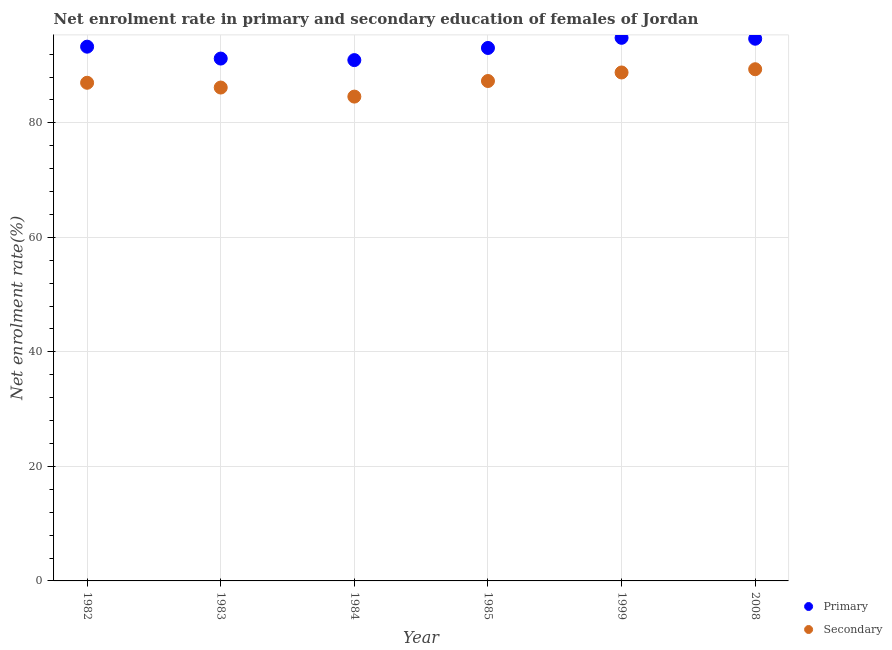How many different coloured dotlines are there?
Offer a very short reply. 2. What is the enrollment rate in primary education in 1985?
Your response must be concise. 93.08. Across all years, what is the maximum enrollment rate in primary education?
Give a very brief answer. 94.85. Across all years, what is the minimum enrollment rate in secondary education?
Offer a terse response. 84.59. In which year was the enrollment rate in primary education minimum?
Give a very brief answer. 1984. What is the total enrollment rate in secondary education in the graph?
Ensure brevity in your answer.  523.24. What is the difference between the enrollment rate in secondary education in 1982 and that in 1985?
Your answer should be compact. -0.31. What is the difference between the enrollment rate in secondary education in 1985 and the enrollment rate in primary education in 1999?
Ensure brevity in your answer.  -7.54. What is the average enrollment rate in secondary education per year?
Your answer should be compact. 87.21. In the year 1983, what is the difference between the enrollment rate in secondary education and enrollment rate in primary education?
Provide a succinct answer. -5.06. What is the ratio of the enrollment rate in primary education in 1982 to that in 1999?
Provide a succinct answer. 0.98. What is the difference between the highest and the second highest enrollment rate in secondary education?
Your answer should be compact. 0.57. What is the difference between the highest and the lowest enrollment rate in primary education?
Keep it short and to the point. 3.89. Is the enrollment rate in primary education strictly greater than the enrollment rate in secondary education over the years?
Your response must be concise. Yes. How many years are there in the graph?
Make the answer very short. 6. How many legend labels are there?
Provide a short and direct response. 2. How are the legend labels stacked?
Keep it short and to the point. Vertical. What is the title of the graph?
Provide a short and direct response. Net enrolment rate in primary and secondary education of females of Jordan. Does "Nitrous oxide" appear as one of the legend labels in the graph?
Your answer should be compact. No. What is the label or title of the Y-axis?
Offer a very short reply. Net enrolment rate(%). What is the Net enrolment rate(%) of Primary in 1982?
Provide a short and direct response. 93.31. What is the Net enrolment rate(%) in Secondary in 1982?
Your answer should be very brief. 87. What is the Net enrolment rate(%) of Primary in 1983?
Offer a terse response. 91.23. What is the Net enrolment rate(%) in Secondary in 1983?
Provide a succinct answer. 86.17. What is the Net enrolment rate(%) of Primary in 1984?
Your answer should be compact. 90.96. What is the Net enrolment rate(%) in Secondary in 1984?
Offer a very short reply. 84.59. What is the Net enrolment rate(%) in Primary in 1985?
Offer a very short reply. 93.08. What is the Net enrolment rate(%) of Secondary in 1985?
Ensure brevity in your answer.  87.31. What is the Net enrolment rate(%) of Primary in 1999?
Your answer should be very brief. 94.85. What is the Net enrolment rate(%) in Secondary in 1999?
Give a very brief answer. 88.8. What is the Net enrolment rate(%) of Primary in 2008?
Offer a terse response. 94.7. What is the Net enrolment rate(%) in Secondary in 2008?
Make the answer very short. 89.37. Across all years, what is the maximum Net enrolment rate(%) of Primary?
Offer a very short reply. 94.85. Across all years, what is the maximum Net enrolment rate(%) of Secondary?
Provide a short and direct response. 89.37. Across all years, what is the minimum Net enrolment rate(%) in Primary?
Your answer should be compact. 90.96. Across all years, what is the minimum Net enrolment rate(%) in Secondary?
Your answer should be compact. 84.59. What is the total Net enrolment rate(%) in Primary in the graph?
Offer a very short reply. 558.13. What is the total Net enrolment rate(%) of Secondary in the graph?
Provide a short and direct response. 523.24. What is the difference between the Net enrolment rate(%) in Primary in 1982 and that in 1983?
Make the answer very short. 2.08. What is the difference between the Net enrolment rate(%) of Secondary in 1982 and that in 1983?
Provide a succinct answer. 0.83. What is the difference between the Net enrolment rate(%) of Primary in 1982 and that in 1984?
Your answer should be compact. 2.35. What is the difference between the Net enrolment rate(%) of Secondary in 1982 and that in 1984?
Offer a terse response. 2.42. What is the difference between the Net enrolment rate(%) of Primary in 1982 and that in 1985?
Keep it short and to the point. 0.23. What is the difference between the Net enrolment rate(%) of Secondary in 1982 and that in 1985?
Ensure brevity in your answer.  -0.31. What is the difference between the Net enrolment rate(%) in Primary in 1982 and that in 1999?
Offer a terse response. -1.55. What is the difference between the Net enrolment rate(%) in Secondary in 1982 and that in 1999?
Keep it short and to the point. -1.8. What is the difference between the Net enrolment rate(%) in Primary in 1982 and that in 2008?
Your answer should be very brief. -1.39. What is the difference between the Net enrolment rate(%) in Secondary in 1982 and that in 2008?
Provide a succinct answer. -2.37. What is the difference between the Net enrolment rate(%) of Primary in 1983 and that in 1984?
Your answer should be very brief. 0.27. What is the difference between the Net enrolment rate(%) in Secondary in 1983 and that in 1984?
Offer a terse response. 1.58. What is the difference between the Net enrolment rate(%) of Primary in 1983 and that in 1985?
Give a very brief answer. -1.85. What is the difference between the Net enrolment rate(%) in Secondary in 1983 and that in 1985?
Your response must be concise. -1.14. What is the difference between the Net enrolment rate(%) of Primary in 1983 and that in 1999?
Give a very brief answer. -3.62. What is the difference between the Net enrolment rate(%) in Secondary in 1983 and that in 1999?
Give a very brief answer. -2.63. What is the difference between the Net enrolment rate(%) in Primary in 1983 and that in 2008?
Keep it short and to the point. -3.47. What is the difference between the Net enrolment rate(%) of Secondary in 1983 and that in 2008?
Give a very brief answer. -3.2. What is the difference between the Net enrolment rate(%) in Primary in 1984 and that in 1985?
Offer a terse response. -2.12. What is the difference between the Net enrolment rate(%) of Secondary in 1984 and that in 1985?
Give a very brief answer. -2.72. What is the difference between the Net enrolment rate(%) in Primary in 1984 and that in 1999?
Ensure brevity in your answer.  -3.89. What is the difference between the Net enrolment rate(%) of Secondary in 1984 and that in 1999?
Give a very brief answer. -4.21. What is the difference between the Net enrolment rate(%) in Primary in 1984 and that in 2008?
Your answer should be compact. -3.73. What is the difference between the Net enrolment rate(%) of Secondary in 1984 and that in 2008?
Provide a succinct answer. -4.78. What is the difference between the Net enrolment rate(%) in Primary in 1985 and that in 1999?
Your answer should be compact. -1.77. What is the difference between the Net enrolment rate(%) of Secondary in 1985 and that in 1999?
Provide a succinct answer. -1.49. What is the difference between the Net enrolment rate(%) in Primary in 1985 and that in 2008?
Your response must be concise. -1.61. What is the difference between the Net enrolment rate(%) of Secondary in 1985 and that in 2008?
Offer a terse response. -2.06. What is the difference between the Net enrolment rate(%) of Primary in 1999 and that in 2008?
Ensure brevity in your answer.  0.16. What is the difference between the Net enrolment rate(%) in Secondary in 1999 and that in 2008?
Make the answer very short. -0.57. What is the difference between the Net enrolment rate(%) of Primary in 1982 and the Net enrolment rate(%) of Secondary in 1983?
Keep it short and to the point. 7.14. What is the difference between the Net enrolment rate(%) in Primary in 1982 and the Net enrolment rate(%) in Secondary in 1984?
Give a very brief answer. 8.72. What is the difference between the Net enrolment rate(%) of Primary in 1982 and the Net enrolment rate(%) of Secondary in 1985?
Make the answer very short. 6. What is the difference between the Net enrolment rate(%) of Primary in 1982 and the Net enrolment rate(%) of Secondary in 1999?
Your answer should be compact. 4.51. What is the difference between the Net enrolment rate(%) in Primary in 1982 and the Net enrolment rate(%) in Secondary in 2008?
Make the answer very short. 3.94. What is the difference between the Net enrolment rate(%) in Primary in 1983 and the Net enrolment rate(%) in Secondary in 1984?
Give a very brief answer. 6.64. What is the difference between the Net enrolment rate(%) in Primary in 1983 and the Net enrolment rate(%) in Secondary in 1985?
Provide a succinct answer. 3.92. What is the difference between the Net enrolment rate(%) in Primary in 1983 and the Net enrolment rate(%) in Secondary in 1999?
Give a very brief answer. 2.43. What is the difference between the Net enrolment rate(%) in Primary in 1983 and the Net enrolment rate(%) in Secondary in 2008?
Your response must be concise. 1.86. What is the difference between the Net enrolment rate(%) of Primary in 1984 and the Net enrolment rate(%) of Secondary in 1985?
Make the answer very short. 3.65. What is the difference between the Net enrolment rate(%) of Primary in 1984 and the Net enrolment rate(%) of Secondary in 1999?
Keep it short and to the point. 2.16. What is the difference between the Net enrolment rate(%) of Primary in 1984 and the Net enrolment rate(%) of Secondary in 2008?
Make the answer very short. 1.59. What is the difference between the Net enrolment rate(%) of Primary in 1985 and the Net enrolment rate(%) of Secondary in 1999?
Ensure brevity in your answer.  4.28. What is the difference between the Net enrolment rate(%) of Primary in 1985 and the Net enrolment rate(%) of Secondary in 2008?
Offer a terse response. 3.71. What is the difference between the Net enrolment rate(%) of Primary in 1999 and the Net enrolment rate(%) of Secondary in 2008?
Provide a succinct answer. 5.49. What is the average Net enrolment rate(%) of Primary per year?
Your response must be concise. 93.02. What is the average Net enrolment rate(%) in Secondary per year?
Keep it short and to the point. 87.21. In the year 1982, what is the difference between the Net enrolment rate(%) of Primary and Net enrolment rate(%) of Secondary?
Ensure brevity in your answer.  6.3. In the year 1983, what is the difference between the Net enrolment rate(%) in Primary and Net enrolment rate(%) in Secondary?
Your response must be concise. 5.06. In the year 1984, what is the difference between the Net enrolment rate(%) of Primary and Net enrolment rate(%) of Secondary?
Offer a very short reply. 6.37. In the year 1985, what is the difference between the Net enrolment rate(%) of Primary and Net enrolment rate(%) of Secondary?
Make the answer very short. 5.77. In the year 1999, what is the difference between the Net enrolment rate(%) in Primary and Net enrolment rate(%) in Secondary?
Provide a succinct answer. 6.05. In the year 2008, what is the difference between the Net enrolment rate(%) of Primary and Net enrolment rate(%) of Secondary?
Ensure brevity in your answer.  5.33. What is the ratio of the Net enrolment rate(%) of Primary in 1982 to that in 1983?
Provide a short and direct response. 1.02. What is the ratio of the Net enrolment rate(%) of Secondary in 1982 to that in 1983?
Your answer should be compact. 1.01. What is the ratio of the Net enrolment rate(%) in Primary in 1982 to that in 1984?
Offer a very short reply. 1.03. What is the ratio of the Net enrolment rate(%) in Secondary in 1982 to that in 1984?
Provide a short and direct response. 1.03. What is the ratio of the Net enrolment rate(%) of Primary in 1982 to that in 1985?
Offer a terse response. 1. What is the ratio of the Net enrolment rate(%) in Primary in 1982 to that in 1999?
Offer a terse response. 0.98. What is the ratio of the Net enrolment rate(%) of Secondary in 1982 to that in 1999?
Your response must be concise. 0.98. What is the ratio of the Net enrolment rate(%) of Secondary in 1982 to that in 2008?
Offer a very short reply. 0.97. What is the ratio of the Net enrolment rate(%) of Primary in 1983 to that in 1984?
Your answer should be very brief. 1. What is the ratio of the Net enrolment rate(%) in Secondary in 1983 to that in 1984?
Make the answer very short. 1.02. What is the ratio of the Net enrolment rate(%) in Primary in 1983 to that in 1985?
Provide a short and direct response. 0.98. What is the ratio of the Net enrolment rate(%) of Secondary in 1983 to that in 1985?
Make the answer very short. 0.99. What is the ratio of the Net enrolment rate(%) of Primary in 1983 to that in 1999?
Ensure brevity in your answer.  0.96. What is the ratio of the Net enrolment rate(%) of Secondary in 1983 to that in 1999?
Keep it short and to the point. 0.97. What is the ratio of the Net enrolment rate(%) in Primary in 1983 to that in 2008?
Provide a short and direct response. 0.96. What is the ratio of the Net enrolment rate(%) of Secondary in 1983 to that in 2008?
Give a very brief answer. 0.96. What is the ratio of the Net enrolment rate(%) of Primary in 1984 to that in 1985?
Provide a short and direct response. 0.98. What is the ratio of the Net enrolment rate(%) in Secondary in 1984 to that in 1985?
Offer a very short reply. 0.97. What is the ratio of the Net enrolment rate(%) in Primary in 1984 to that in 1999?
Provide a short and direct response. 0.96. What is the ratio of the Net enrolment rate(%) of Secondary in 1984 to that in 1999?
Your response must be concise. 0.95. What is the ratio of the Net enrolment rate(%) in Primary in 1984 to that in 2008?
Offer a very short reply. 0.96. What is the ratio of the Net enrolment rate(%) in Secondary in 1984 to that in 2008?
Ensure brevity in your answer.  0.95. What is the ratio of the Net enrolment rate(%) of Primary in 1985 to that in 1999?
Your response must be concise. 0.98. What is the ratio of the Net enrolment rate(%) of Secondary in 1985 to that in 1999?
Your response must be concise. 0.98. What is the ratio of the Net enrolment rate(%) of Primary in 1985 to that in 2008?
Offer a very short reply. 0.98. What is the ratio of the Net enrolment rate(%) in Secondary in 1985 to that in 2008?
Provide a short and direct response. 0.98. What is the ratio of the Net enrolment rate(%) in Primary in 1999 to that in 2008?
Provide a short and direct response. 1. What is the ratio of the Net enrolment rate(%) of Secondary in 1999 to that in 2008?
Offer a terse response. 0.99. What is the difference between the highest and the second highest Net enrolment rate(%) in Primary?
Ensure brevity in your answer.  0.16. What is the difference between the highest and the second highest Net enrolment rate(%) of Secondary?
Offer a very short reply. 0.57. What is the difference between the highest and the lowest Net enrolment rate(%) of Primary?
Give a very brief answer. 3.89. What is the difference between the highest and the lowest Net enrolment rate(%) in Secondary?
Make the answer very short. 4.78. 